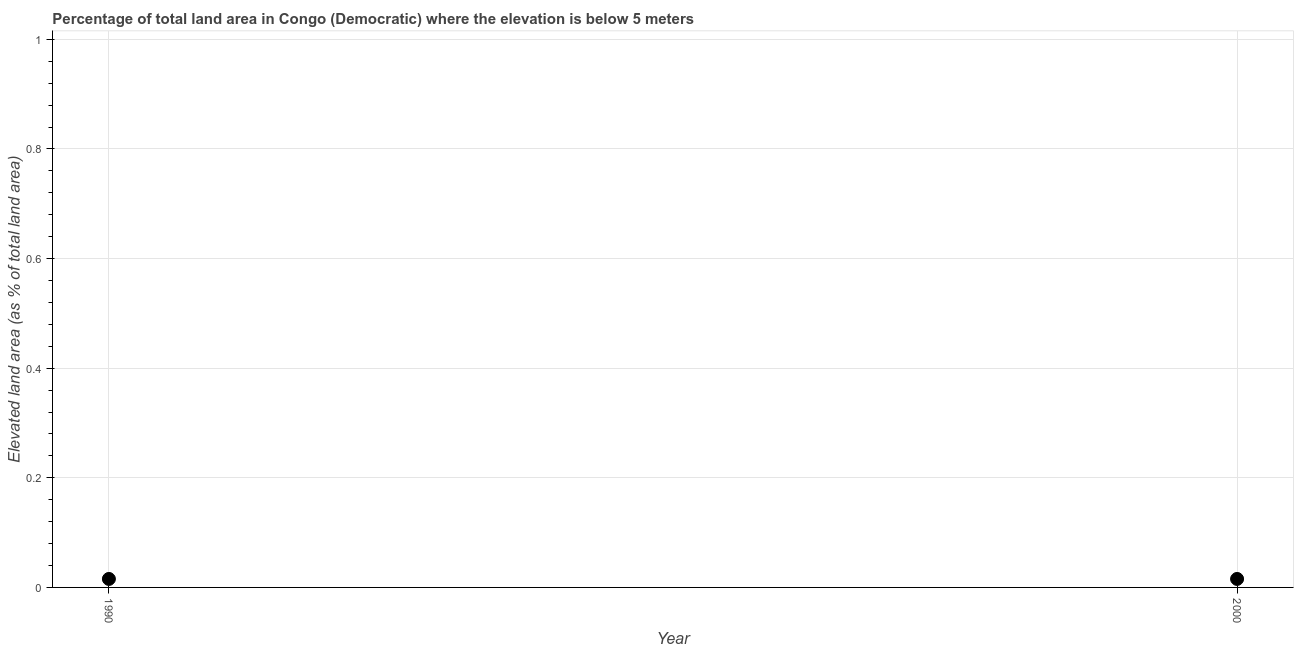What is the total elevated land area in 1990?
Your response must be concise. 0.02. Across all years, what is the maximum total elevated land area?
Your answer should be very brief. 0.02. Across all years, what is the minimum total elevated land area?
Offer a terse response. 0.02. In which year was the total elevated land area maximum?
Keep it short and to the point. 1990. What is the sum of the total elevated land area?
Provide a short and direct response. 0.03. What is the average total elevated land area per year?
Make the answer very short. 0.02. What is the median total elevated land area?
Provide a succinct answer. 0.02. Do a majority of the years between 2000 and 1990 (inclusive) have total elevated land area greater than 0.2 %?
Give a very brief answer. No. Is the total elevated land area in 1990 less than that in 2000?
Your answer should be compact. No. In how many years, is the total elevated land area greater than the average total elevated land area taken over all years?
Provide a succinct answer. 0. How many dotlines are there?
Your answer should be very brief. 1. What is the difference between two consecutive major ticks on the Y-axis?
Your answer should be compact. 0.2. Are the values on the major ticks of Y-axis written in scientific E-notation?
Keep it short and to the point. No. Does the graph contain any zero values?
Provide a short and direct response. No. Does the graph contain grids?
Offer a very short reply. Yes. What is the title of the graph?
Offer a terse response. Percentage of total land area in Congo (Democratic) where the elevation is below 5 meters. What is the label or title of the Y-axis?
Keep it short and to the point. Elevated land area (as % of total land area). What is the Elevated land area (as % of total land area) in 1990?
Give a very brief answer. 0.02. What is the Elevated land area (as % of total land area) in 2000?
Offer a terse response. 0.02. What is the difference between the Elevated land area (as % of total land area) in 1990 and 2000?
Offer a very short reply. 0. 